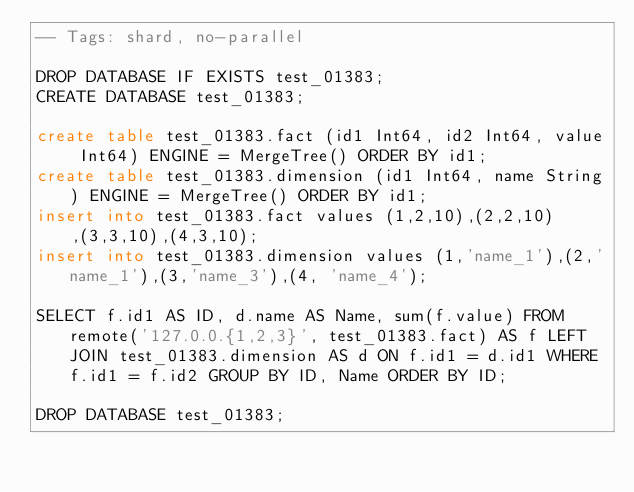<code> <loc_0><loc_0><loc_500><loc_500><_SQL_>-- Tags: shard, no-parallel

DROP DATABASE IF EXISTS test_01383;
CREATE DATABASE test_01383;

create table test_01383.fact (id1 Int64, id2 Int64, value Int64) ENGINE = MergeTree() ORDER BY id1;
create table test_01383.dimension (id1 Int64, name String) ENGINE = MergeTree() ORDER BY id1;
insert into test_01383.fact values (1,2,10),(2,2,10),(3,3,10),(4,3,10);
insert into test_01383.dimension values (1,'name_1'),(2,'name_1'),(3,'name_3'),(4, 'name_4');

SELECT f.id1 AS ID, d.name AS Name, sum(f.value) FROM remote('127.0.0.{1,2,3}', test_01383.fact) AS f LEFT JOIN test_01383.dimension AS d ON f.id1 = d.id1 WHERE f.id1 = f.id2 GROUP BY ID, Name ORDER BY ID;

DROP DATABASE test_01383;
</code> 